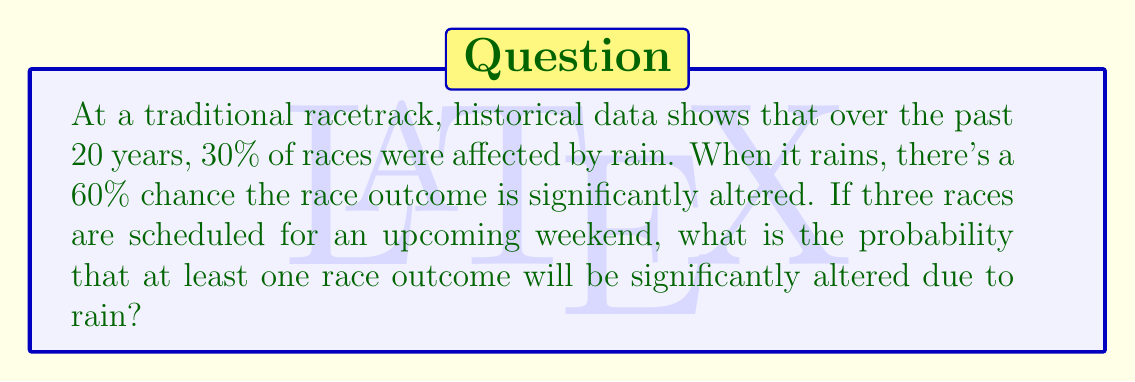Help me with this question. Let's approach this step-by-step:

1) First, let's define our events:
   R: It rains on a race day
   A: The race outcome is significantly altered

2) We're given:
   P(R) = 0.30 (probability of rain on a race day)
   P(A|R) = 0.60 (probability of altered outcome given that it rains)

3) We need to find P(A) for a single race:
   P(A) = P(A|R) * P(R) = 0.60 * 0.30 = 0.18

4) So, for a single race:
   P(race outcome is not altered) = 1 - P(A) = 1 - 0.18 = 0.82

5) For three races, we want the probability that at least one is altered. It's easier to calculate the probability that none are altered and then subtract from 1:

   P(no races altered) = $(0.82)^3 = 0.551368$

6) Therefore:
   P(at least one race altered) = 1 - P(no races altered)
                                 = $1 - 0.551368 = 0.448632$
Answer: 0.4486 (rounded to 4 decimal places) 